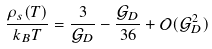Convert formula to latex. <formula><loc_0><loc_0><loc_500><loc_500>\frac { \rho _ { s } ( T ) } { k _ { B } T } = \frac { 3 } { \mathcal { G } _ { D } } - \frac { \mathcal { G } _ { D } } { 3 6 } + \mathcal { O } ( \mathcal { G } _ { D } ^ { 2 } )</formula> 